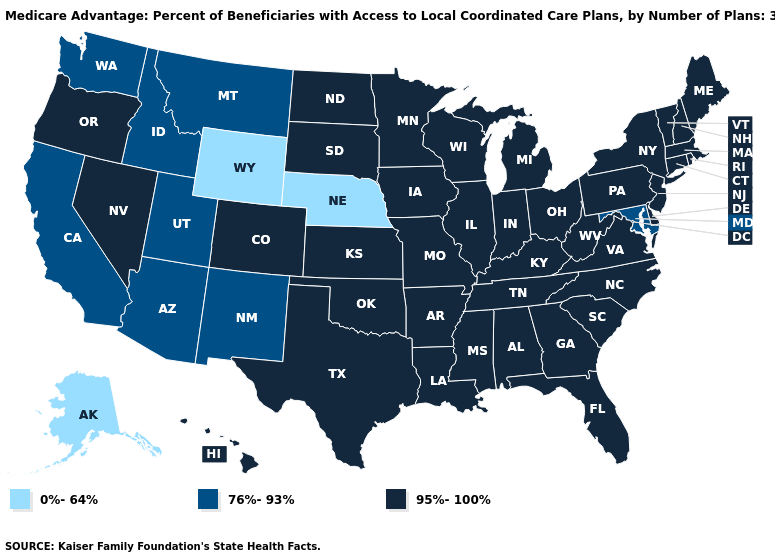Name the states that have a value in the range 0%-64%?
Short answer required. Nebraska, Alaska, Wyoming. Does New Jersey have a higher value than Nebraska?
Give a very brief answer. Yes. What is the value of South Carolina?
Concise answer only. 95%-100%. What is the value of Michigan?
Be succinct. 95%-100%. Name the states that have a value in the range 95%-100%?
Concise answer only. Colorado, Connecticut, Delaware, Florida, Georgia, Hawaii, Iowa, Illinois, Indiana, Kansas, Kentucky, Louisiana, Massachusetts, Maine, Michigan, Minnesota, Missouri, Mississippi, North Carolina, North Dakota, New Hampshire, New Jersey, Nevada, New York, Ohio, Oklahoma, Oregon, Pennsylvania, Rhode Island, South Carolina, South Dakota, Tennessee, Texas, Virginia, Vermont, Wisconsin, West Virginia, Alabama, Arkansas. Among the states that border Vermont , which have the lowest value?
Keep it brief. Massachusetts, New Hampshire, New York. Does Nebraska have the highest value in the USA?
Concise answer only. No. Which states have the lowest value in the South?
Concise answer only. Maryland. What is the value of Indiana?
Keep it brief. 95%-100%. Name the states that have a value in the range 76%-93%?
Keep it brief. California, Idaho, Maryland, Montana, New Mexico, Utah, Washington, Arizona. Name the states that have a value in the range 76%-93%?
Quick response, please. California, Idaho, Maryland, Montana, New Mexico, Utah, Washington, Arizona. Name the states that have a value in the range 76%-93%?
Write a very short answer. California, Idaho, Maryland, Montana, New Mexico, Utah, Washington, Arizona. Does Washington have a higher value than Nebraska?
Short answer required. Yes. Which states have the lowest value in the USA?
Keep it brief. Nebraska, Alaska, Wyoming. 